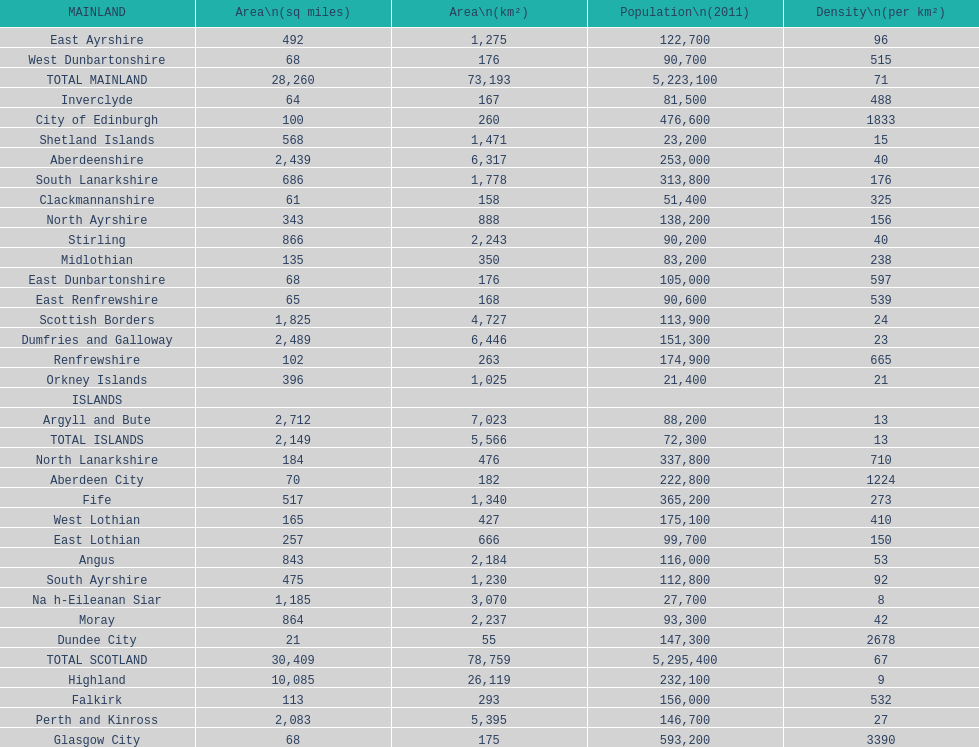What is the total area of east lothian, angus, and dundee city? 1121. Parse the full table. {'header': ['MAINLAND', 'Area\\n(sq miles)', 'Area\\n(km²)', 'Population\\n(2011)', 'Density\\n(per km²)'], 'rows': [['East Ayrshire', '492', '1,275', '122,700', '96'], ['West Dunbartonshire', '68', '176', '90,700', '515'], ['TOTAL MAINLAND', '28,260', '73,193', '5,223,100', '71'], ['Inverclyde', '64', '167', '81,500', '488'], ['City of Edinburgh', '100', '260', '476,600', '1833'], ['Shetland Islands', '568', '1,471', '23,200', '15'], ['Aberdeenshire', '2,439', '6,317', '253,000', '40'], ['South Lanarkshire', '686', '1,778', '313,800', '176'], ['Clackmannanshire', '61', '158', '51,400', '325'], ['North Ayrshire', '343', '888', '138,200', '156'], ['Stirling', '866', '2,243', '90,200', '40'], ['Midlothian', '135', '350', '83,200', '238'], ['East Dunbartonshire', '68', '176', '105,000', '597'], ['East Renfrewshire', '65', '168', '90,600', '539'], ['Scottish Borders', '1,825', '4,727', '113,900', '24'], ['Dumfries and Galloway', '2,489', '6,446', '151,300', '23'], ['Renfrewshire', '102', '263', '174,900', '665'], ['Orkney Islands', '396', '1,025', '21,400', '21'], ['ISLANDS', '', '', '', ''], ['Argyll and Bute', '2,712', '7,023', '88,200', '13'], ['TOTAL ISLANDS', '2,149', '5,566', '72,300', '13'], ['North Lanarkshire', '184', '476', '337,800', '710'], ['Aberdeen City', '70', '182', '222,800', '1224'], ['Fife', '517', '1,340', '365,200', '273'], ['West Lothian', '165', '427', '175,100', '410'], ['East Lothian', '257', '666', '99,700', '150'], ['Angus', '843', '2,184', '116,000', '53'], ['South Ayrshire', '475', '1,230', '112,800', '92'], ['Na h-Eileanan Siar', '1,185', '3,070', '27,700', '8'], ['Moray', '864', '2,237', '93,300', '42'], ['Dundee City', '21', '55', '147,300', '2678'], ['TOTAL SCOTLAND', '30,409', '78,759', '5,295,400', '67'], ['Highland', '10,085', '26,119', '232,100', '9'], ['Falkirk', '113', '293', '156,000', '532'], ['Perth and Kinross', '2,083', '5,395', '146,700', '27'], ['Glasgow City', '68', '175', '593,200', '3390']]} 